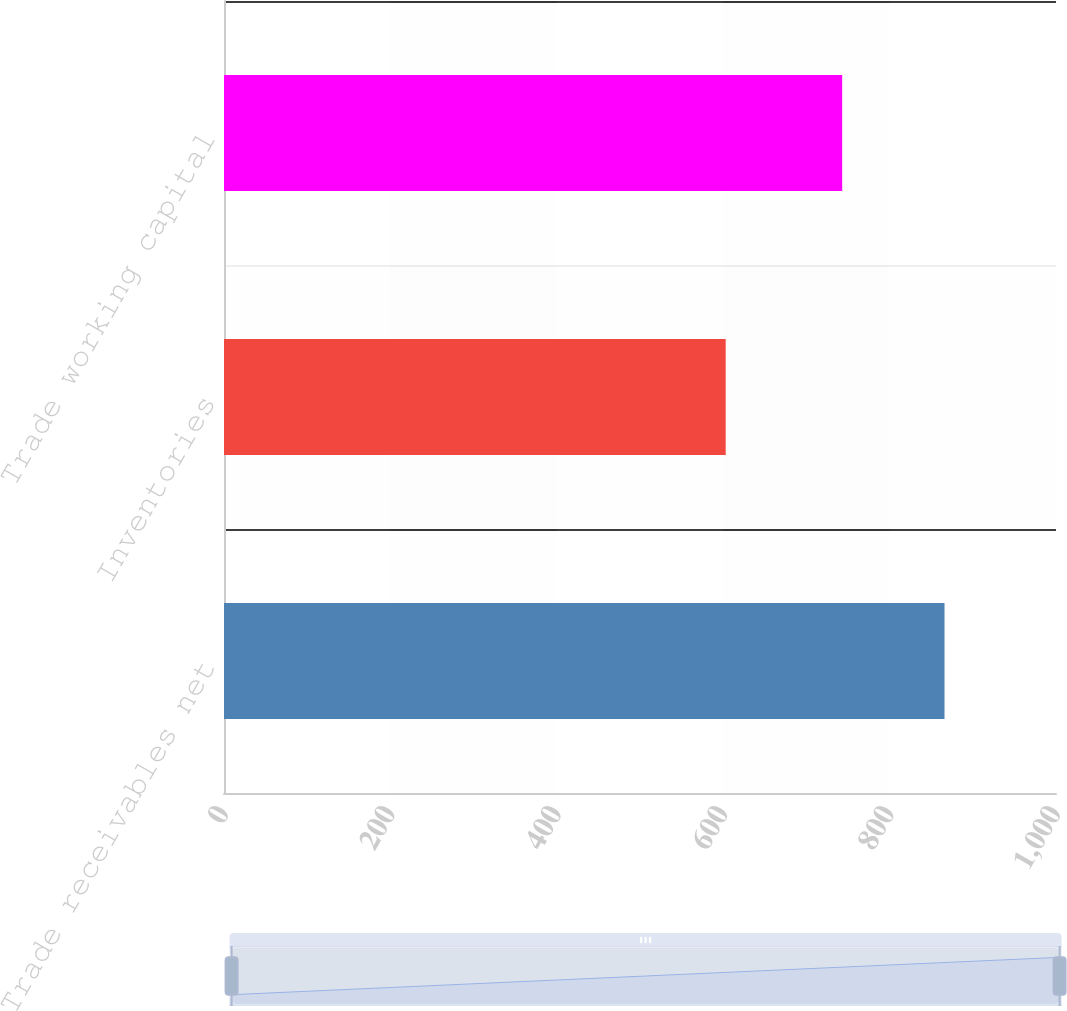Convert chart to OTSL. <chart><loc_0><loc_0><loc_500><loc_500><bar_chart><fcel>Trade receivables net<fcel>Inventories<fcel>Trade working capital<nl><fcel>866<fcel>603<fcel>743<nl></chart> 